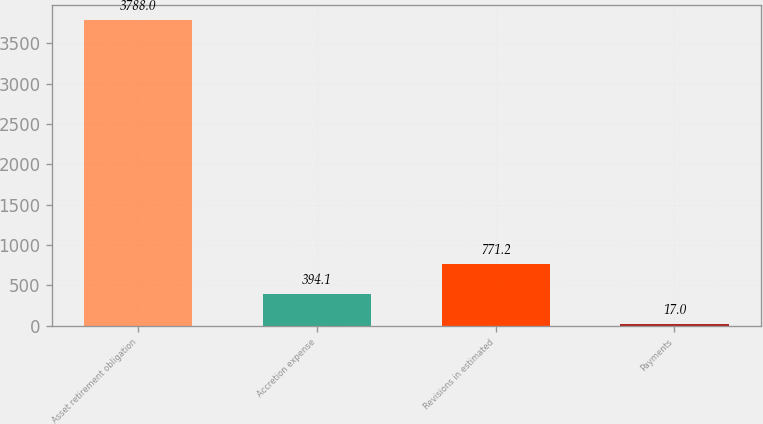<chart> <loc_0><loc_0><loc_500><loc_500><bar_chart><fcel>Asset retirement obligation<fcel>Accretion expense<fcel>Revisions in estimated<fcel>Payments<nl><fcel>3788<fcel>394.1<fcel>771.2<fcel>17<nl></chart> 